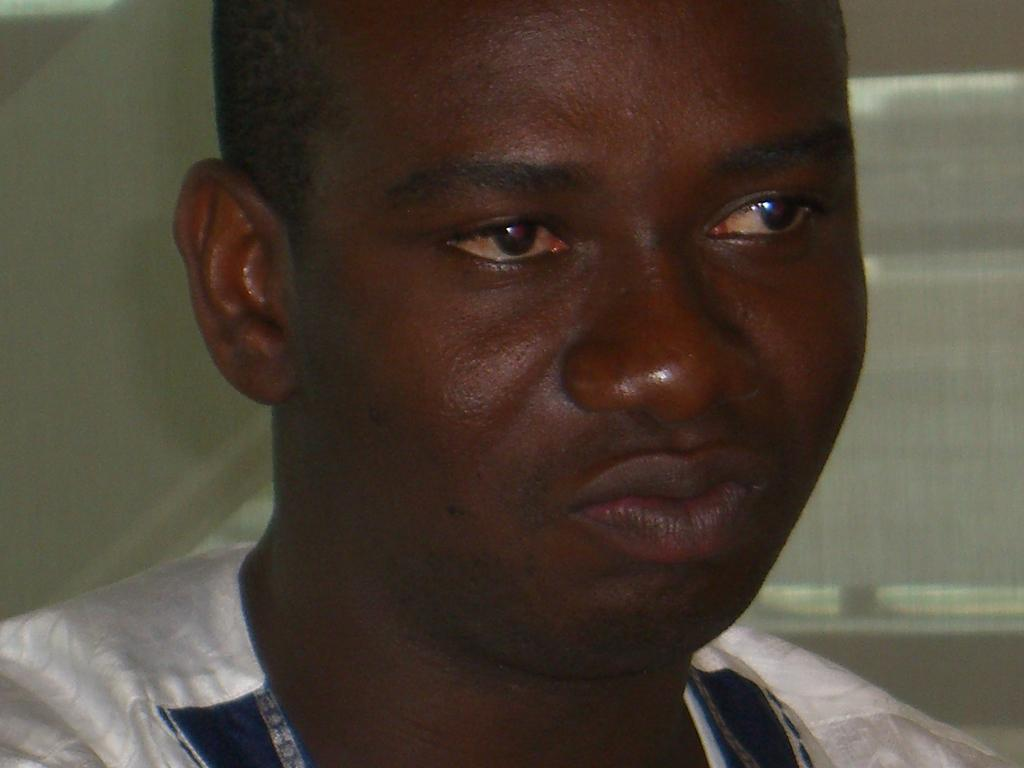What is the main subject of the image? There is a person in the image. What is the person wearing? The person is wearing a white dress. What color is the background of the image? The background of the image is white. What caused the burst of color in the image? There is no burst of color present in the image; it features a person wearing a white dress against a white background. 